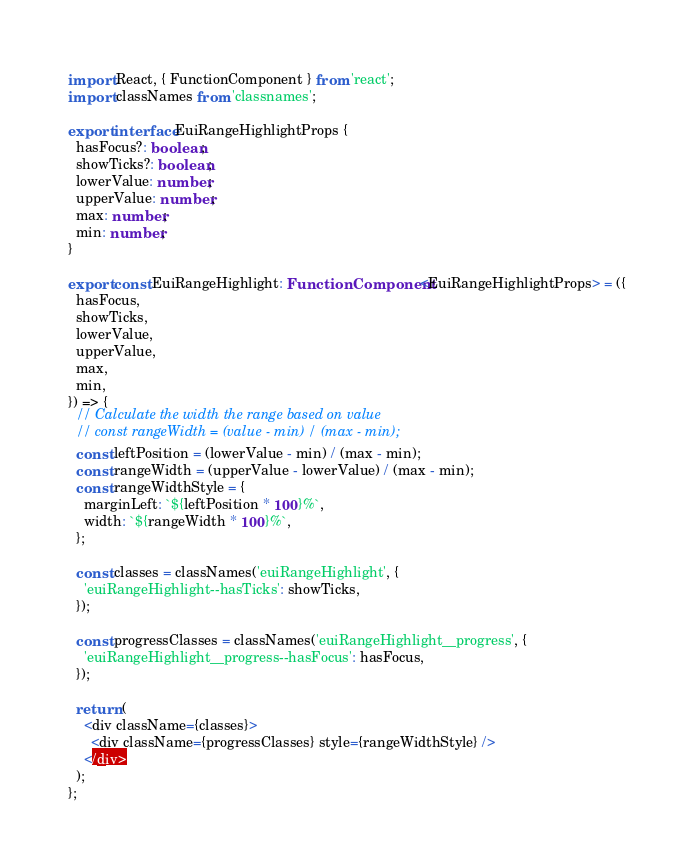<code> <loc_0><loc_0><loc_500><loc_500><_TypeScript_>import React, { FunctionComponent } from 'react';
import classNames from 'classnames';

export interface EuiRangeHighlightProps {
  hasFocus?: boolean;
  showTicks?: boolean;
  lowerValue: number;
  upperValue: number;
  max: number;
  min: number;
}

export const EuiRangeHighlight: FunctionComponent<EuiRangeHighlightProps> = ({
  hasFocus,
  showTicks,
  lowerValue,
  upperValue,
  max,
  min,
}) => {
  // Calculate the width the range based on value
  // const rangeWidth = (value - min) / (max - min);
  const leftPosition = (lowerValue - min) / (max - min);
  const rangeWidth = (upperValue - lowerValue) / (max - min);
  const rangeWidthStyle = {
    marginLeft: `${leftPosition * 100}%`,
    width: `${rangeWidth * 100}%`,
  };

  const classes = classNames('euiRangeHighlight', {
    'euiRangeHighlight--hasTicks': showTicks,
  });

  const progressClasses = classNames('euiRangeHighlight__progress', {
    'euiRangeHighlight__progress--hasFocus': hasFocus,
  });

  return (
    <div className={classes}>
      <div className={progressClasses} style={rangeWidthStyle} />
    </div>
  );
};
</code> 